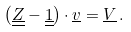Convert formula to latex. <formula><loc_0><loc_0><loc_500><loc_500>\left ( \underline { \underline { Z } } - \underline { \underline { 1 } } \right ) \cdot \underline { v } = \underline { V } \, .</formula> 